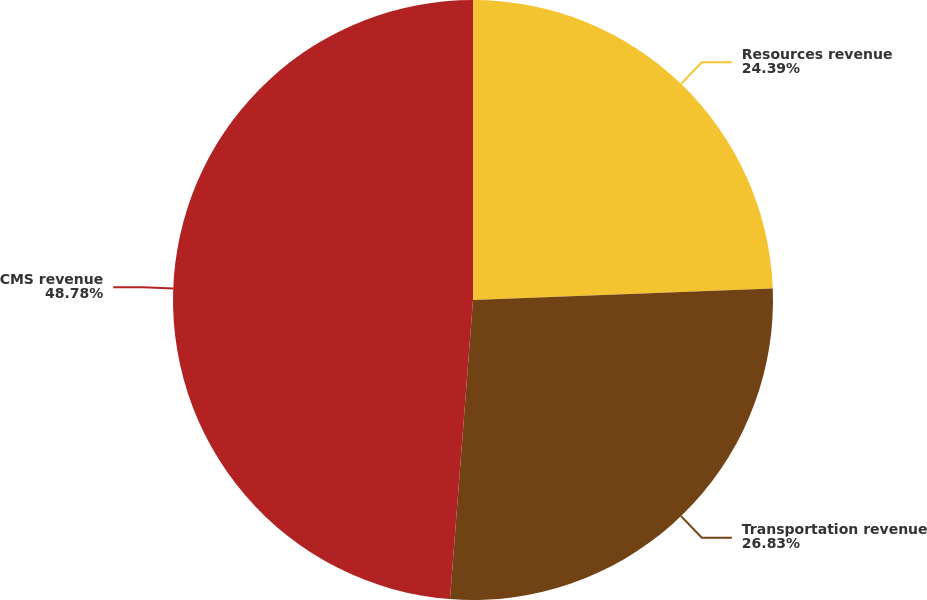Convert chart to OTSL. <chart><loc_0><loc_0><loc_500><loc_500><pie_chart><fcel>Resources revenue<fcel>Transportation revenue<fcel>CMS revenue<nl><fcel>24.39%<fcel>26.83%<fcel>48.78%<nl></chart> 